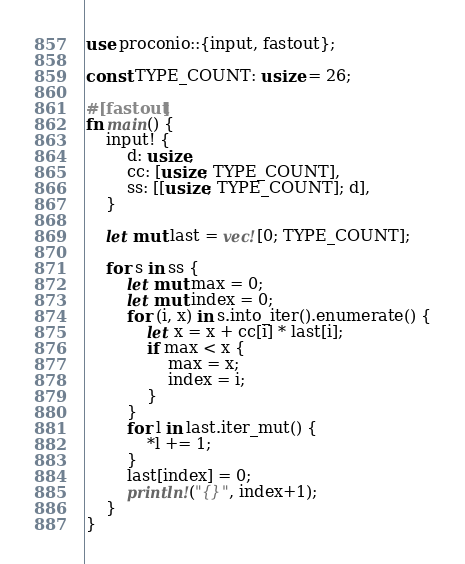Convert code to text. <code><loc_0><loc_0><loc_500><loc_500><_Rust_>use proconio::{input, fastout};

const TYPE_COUNT: usize = 26;

#[fastout]
fn main() {
    input! {
        d: usize,
        cc: [usize; TYPE_COUNT],
        ss: [[usize; TYPE_COUNT]; d],
    }

    let mut last = vec![0; TYPE_COUNT];

    for s in ss {
        let mut max = 0;
        let mut index = 0;
        for (i, x) in s.into_iter().enumerate() {
            let x = x + cc[i] * last[i];
            if max < x {
                max = x;
                index = i;
            }
        }
        for l in last.iter_mut() {
            *l += 1;
        }
        last[index] = 0;
        println!("{}", index+1);
    }
}</code> 